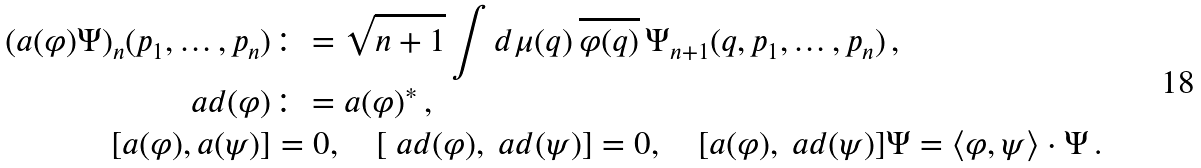<formula> <loc_0><loc_0><loc_500><loc_500>( a ( \varphi ) \Psi ) _ { n } ( p _ { 1 } , \dots , p _ { n } ) & \colon = \sqrt { n + 1 } \int d \mu ( q ) \, \overline { \varphi ( q ) } \, \Psi _ { n + 1 } ( q , p _ { 1 } , \dots , p _ { n } ) \, , \\ \ a d ( \varphi ) & \colon = a ( \varphi ) ^ { * } \, , \\ [ a ( \varphi ) , a ( \psi ) ] & = 0 , \quad [ \ a d ( \varphi ) , \ a d ( \psi ) ] = 0 , \quad [ a ( \varphi ) , \ a d ( \psi ) ] \Psi = \langle \varphi , \psi \rangle \cdot \Psi \, .</formula> 